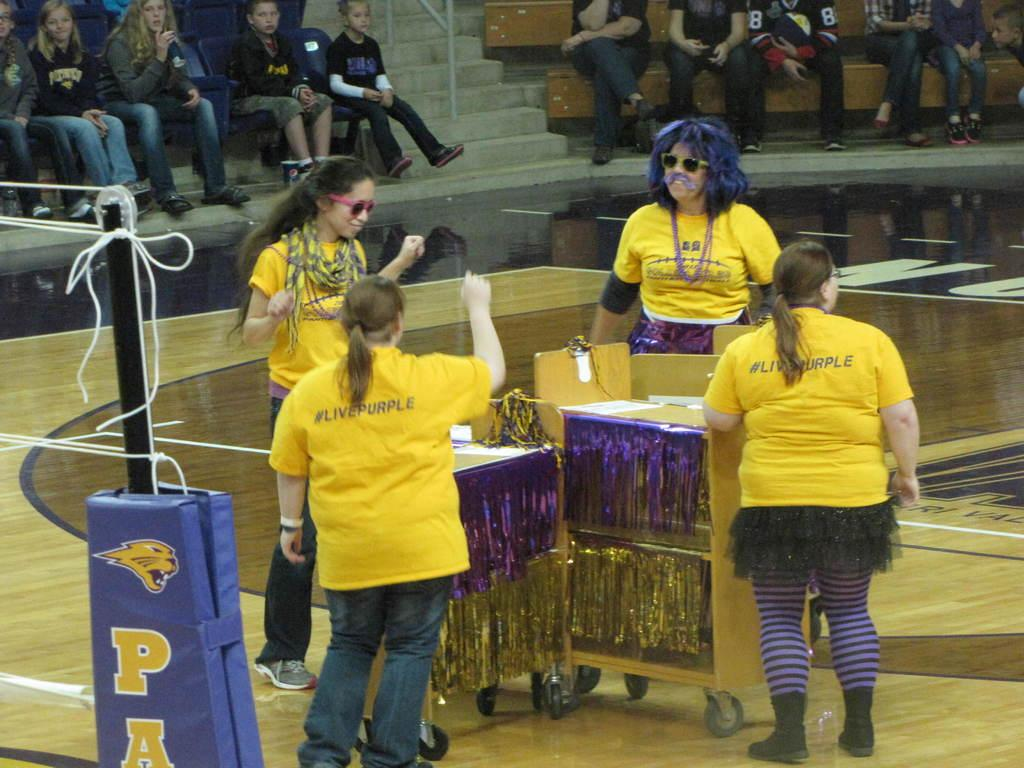What is the general activity of the people in the image? The people in the image are either sitting or standing. Can you describe the clothing of the people in the image? The people in the image are wearing yellow color T-shirts. What is present on the floor in the image? There are objects on the floor. What type of design is visible on the agreement in the image? There is no agreement present in the image, so it is not possible to determine any design. 